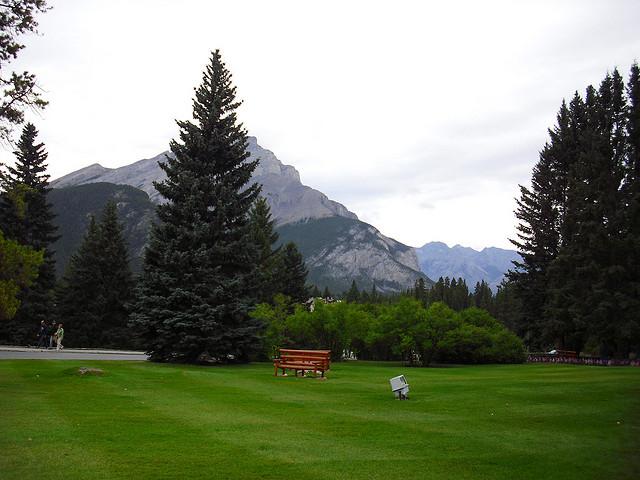There are mountains in the background?
Quick response, please. Yes. Are there mountains in the background?
Answer briefly. Yes. How many benches are in the photo?
Give a very brief answer. 1. 